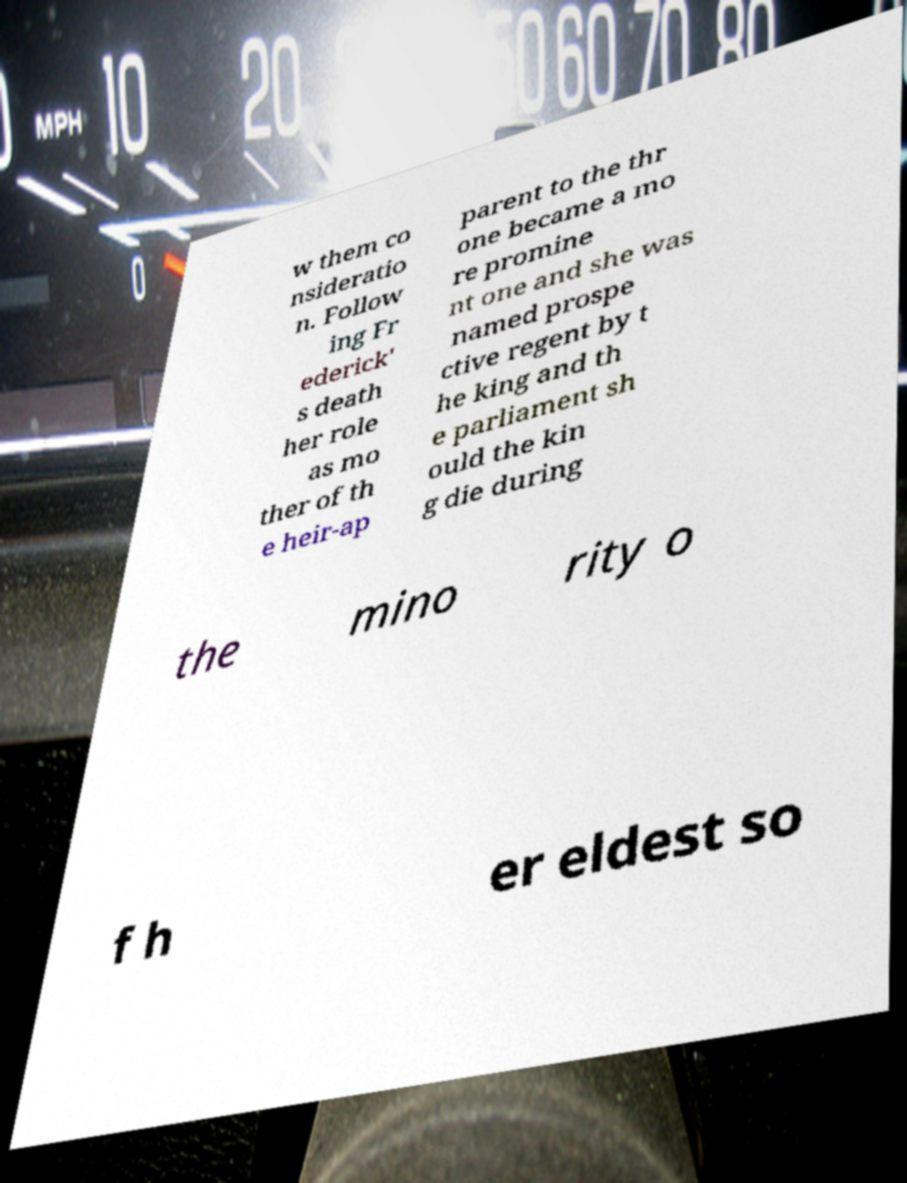I need the written content from this picture converted into text. Can you do that? w them co nsideratio n. Follow ing Fr ederick' s death her role as mo ther of th e heir-ap parent to the thr one became a mo re promine nt one and she was named prospe ctive regent by t he king and th e parliament sh ould the kin g die during the mino rity o f h er eldest so 